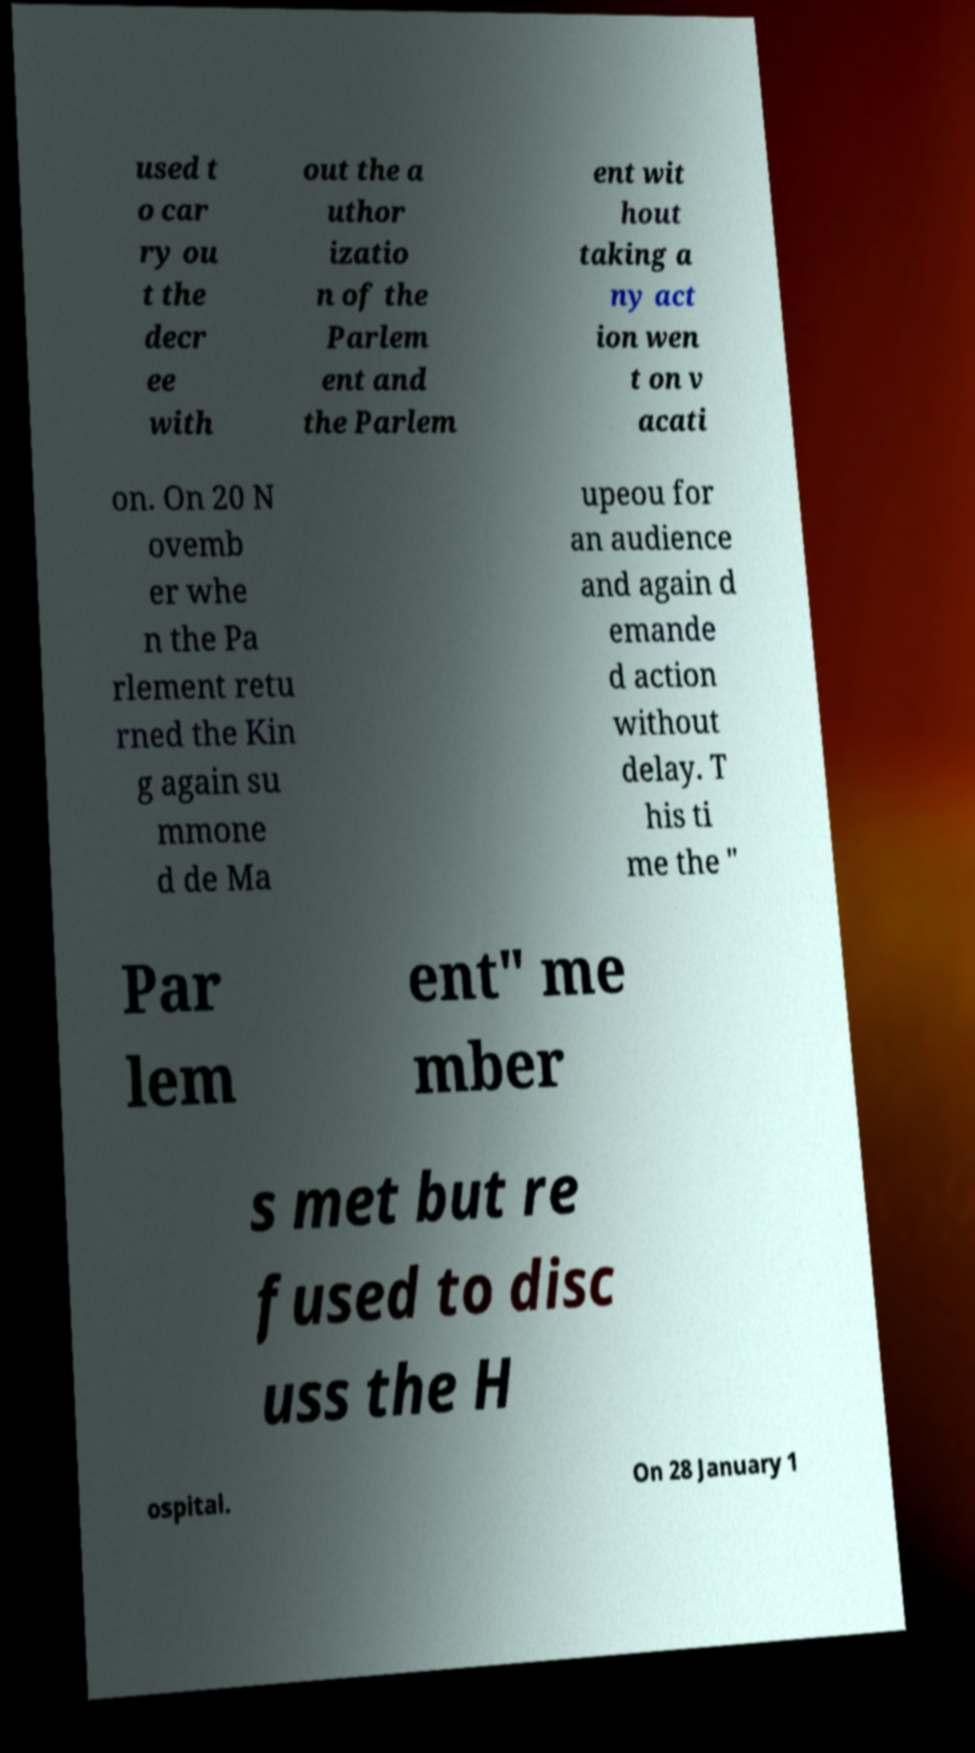Can you read and provide the text displayed in the image?This photo seems to have some interesting text. Can you extract and type it out for me? used t o car ry ou t the decr ee with out the a uthor izatio n of the Parlem ent and the Parlem ent wit hout taking a ny act ion wen t on v acati on. On 20 N ovemb er whe n the Pa rlement retu rned the Kin g again su mmone d de Ma upeou for an audience and again d emande d action without delay. T his ti me the " Par lem ent" me mber s met but re fused to disc uss the H ospital. On 28 January 1 